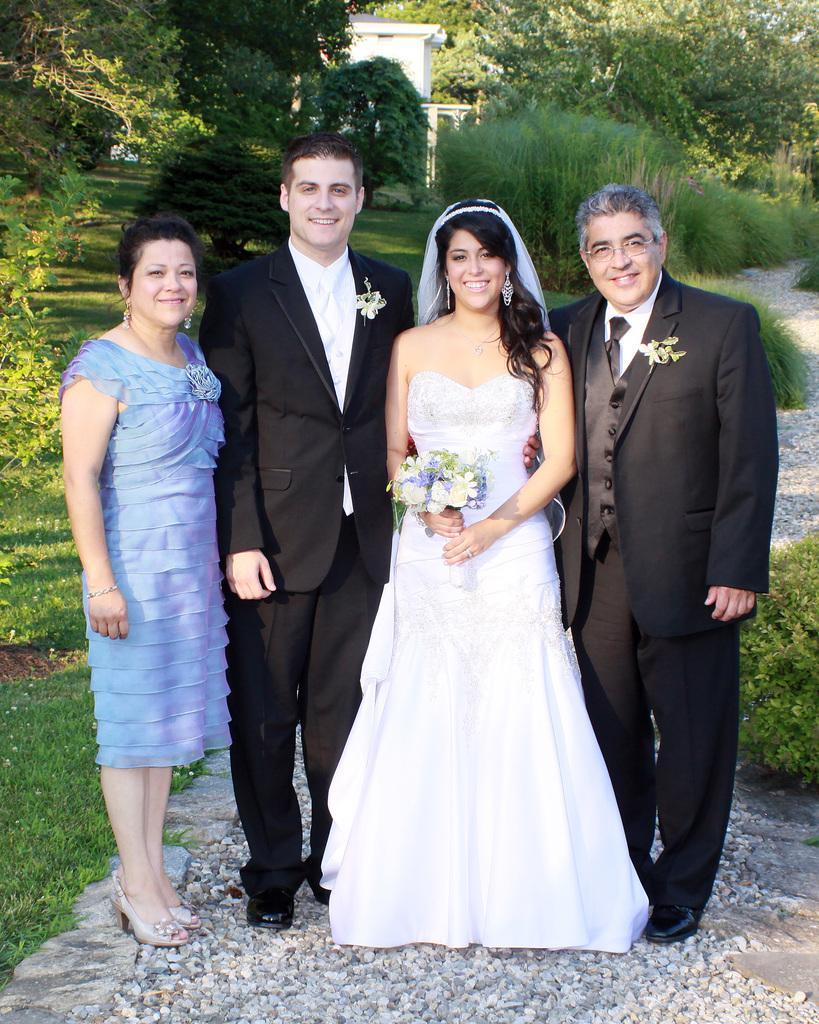Can you describe this image briefly? In this image in front there are four people wearing a smile on their faces. At the bottom of the image there are stones. On the left side of the image there is grass on the surface. In the background of the image there is a building. There are trees. 